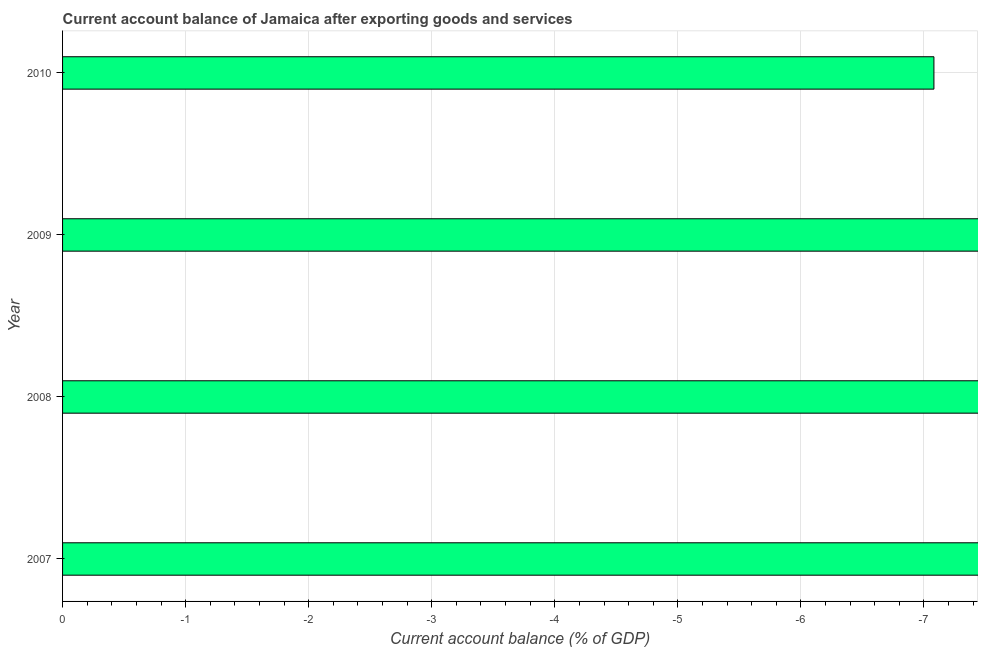Does the graph contain any zero values?
Offer a very short reply. Yes. What is the title of the graph?
Give a very brief answer. Current account balance of Jamaica after exporting goods and services. What is the label or title of the X-axis?
Offer a terse response. Current account balance (% of GDP). Across all years, what is the minimum current account balance?
Keep it short and to the point. 0. What is the sum of the current account balance?
Offer a very short reply. 0. In how many years, is the current account balance greater than the average current account balance taken over all years?
Ensure brevity in your answer.  0. How many bars are there?
Provide a succinct answer. 0. Are all the bars in the graph horizontal?
Give a very brief answer. Yes. How many years are there in the graph?
Provide a succinct answer. 4. What is the Current account balance (% of GDP) in 2007?
Give a very brief answer. 0. What is the Current account balance (% of GDP) of 2008?
Provide a succinct answer. 0. 